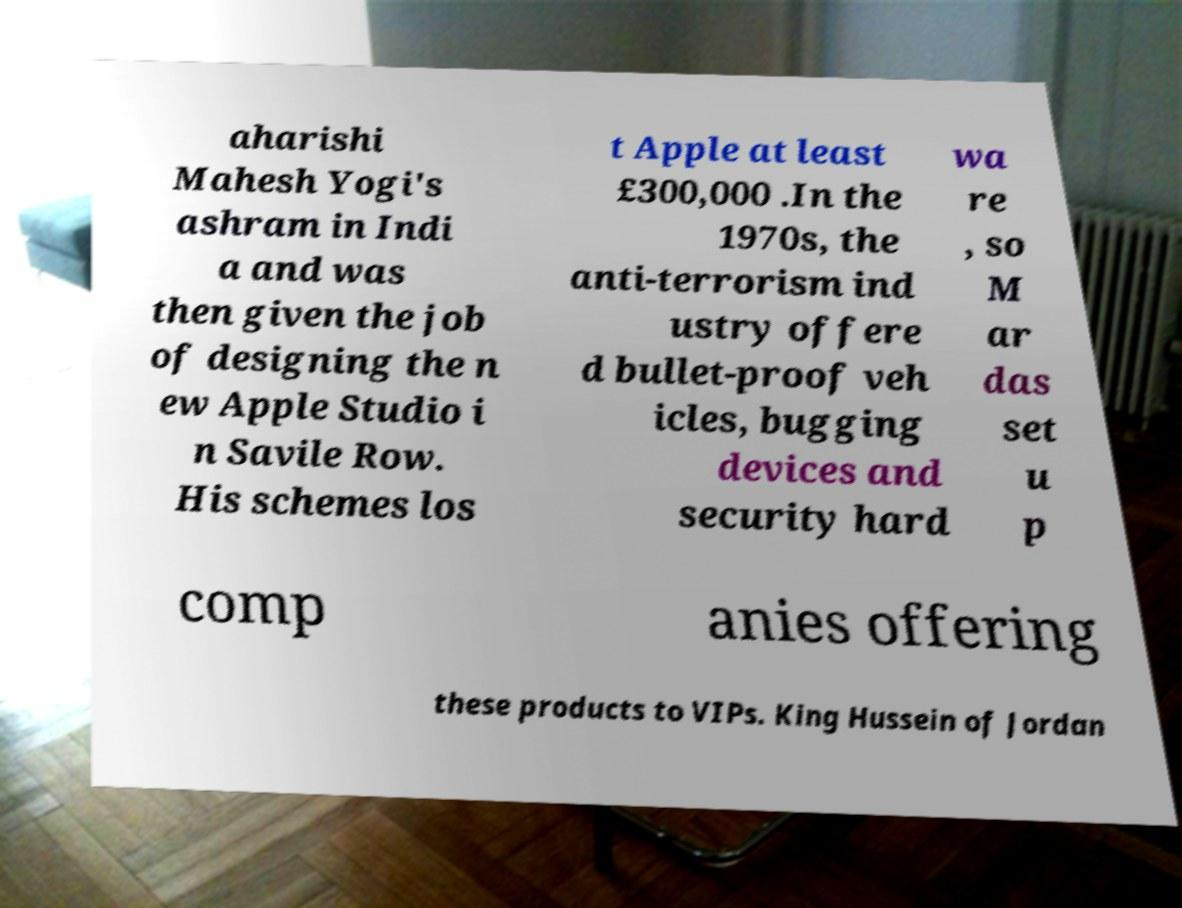I need the written content from this picture converted into text. Can you do that? aharishi Mahesh Yogi's ashram in Indi a and was then given the job of designing the n ew Apple Studio i n Savile Row. His schemes los t Apple at least £300,000 .In the 1970s, the anti-terrorism ind ustry offere d bullet-proof veh icles, bugging devices and security hard wa re , so M ar das set u p comp anies offering these products to VIPs. King Hussein of Jordan 